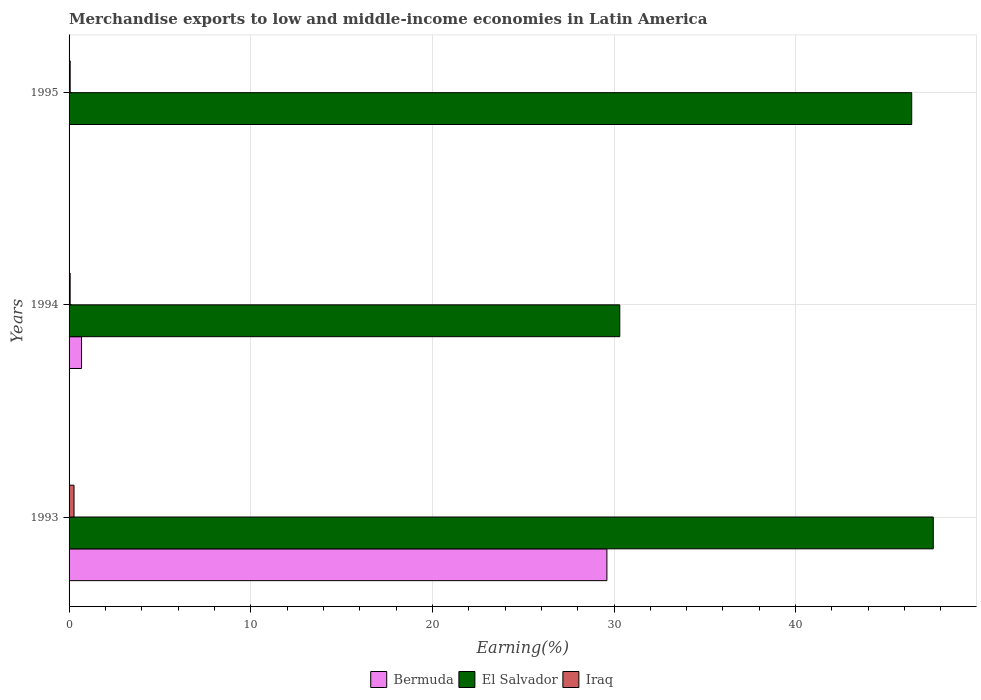How many groups of bars are there?
Provide a succinct answer. 3. How many bars are there on the 2nd tick from the top?
Ensure brevity in your answer.  3. What is the label of the 3rd group of bars from the top?
Provide a short and direct response. 1993. In how many cases, is the number of bars for a given year not equal to the number of legend labels?
Your response must be concise. 0. What is the percentage of amount earned from merchandise exports in Iraq in 1993?
Make the answer very short. 0.27. Across all years, what is the maximum percentage of amount earned from merchandise exports in Bermuda?
Keep it short and to the point. 29.61. Across all years, what is the minimum percentage of amount earned from merchandise exports in Iraq?
Keep it short and to the point. 0.06. In which year was the percentage of amount earned from merchandise exports in Bermuda maximum?
Your answer should be very brief. 1993. In which year was the percentage of amount earned from merchandise exports in Iraq minimum?
Your answer should be compact. 1994. What is the total percentage of amount earned from merchandise exports in Iraq in the graph?
Keep it short and to the point. 0.39. What is the difference between the percentage of amount earned from merchandise exports in Bermuda in 1993 and that in 1995?
Provide a short and direct response. 29.61. What is the difference between the percentage of amount earned from merchandise exports in Iraq in 1993 and the percentage of amount earned from merchandise exports in El Salvador in 1994?
Provide a succinct answer. -30.05. What is the average percentage of amount earned from merchandise exports in El Salvador per year?
Give a very brief answer. 41.43. In the year 1994, what is the difference between the percentage of amount earned from merchandise exports in El Salvador and percentage of amount earned from merchandise exports in Iraq?
Provide a short and direct response. 30.26. In how many years, is the percentage of amount earned from merchandise exports in Iraq greater than 46 %?
Provide a short and direct response. 0. What is the ratio of the percentage of amount earned from merchandise exports in El Salvador in 1994 to that in 1995?
Offer a terse response. 0.65. Is the difference between the percentage of amount earned from merchandise exports in El Salvador in 1993 and 1995 greater than the difference between the percentage of amount earned from merchandise exports in Iraq in 1993 and 1995?
Ensure brevity in your answer.  Yes. What is the difference between the highest and the second highest percentage of amount earned from merchandise exports in Iraq?
Your answer should be compact. 0.21. What is the difference between the highest and the lowest percentage of amount earned from merchandise exports in El Salvador?
Your answer should be very brief. 17.26. In how many years, is the percentage of amount earned from merchandise exports in El Salvador greater than the average percentage of amount earned from merchandise exports in El Salvador taken over all years?
Keep it short and to the point. 2. Is the sum of the percentage of amount earned from merchandise exports in Iraq in 1993 and 1994 greater than the maximum percentage of amount earned from merchandise exports in El Salvador across all years?
Make the answer very short. No. What does the 3rd bar from the top in 1993 represents?
Your answer should be very brief. Bermuda. What does the 2nd bar from the bottom in 1995 represents?
Provide a short and direct response. El Salvador. How many bars are there?
Offer a terse response. 9. What is the difference between two consecutive major ticks on the X-axis?
Make the answer very short. 10. Does the graph contain any zero values?
Ensure brevity in your answer.  No. Does the graph contain grids?
Provide a short and direct response. Yes. Where does the legend appear in the graph?
Provide a succinct answer. Bottom center. What is the title of the graph?
Make the answer very short. Merchandise exports to low and middle-income economies in Latin America. Does "Czech Republic" appear as one of the legend labels in the graph?
Provide a short and direct response. No. What is the label or title of the X-axis?
Provide a short and direct response. Earning(%). What is the label or title of the Y-axis?
Offer a terse response. Years. What is the Earning(%) of Bermuda in 1993?
Your answer should be compact. 29.61. What is the Earning(%) of El Salvador in 1993?
Your response must be concise. 47.58. What is the Earning(%) of Iraq in 1993?
Your answer should be compact. 0.27. What is the Earning(%) of Bermuda in 1994?
Give a very brief answer. 0.69. What is the Earning(%) of El Salvador in 1994?
Offer a terse response. 30.32. What is the Earning(%) in Iraq in 1994?
Offer a very short reply. 0.06. What is the Earning(%) of Bermuda in 1995?
Your response must be concise. 8.26324880050998e-5. What is the Earning(%) of El Salvador in 1995?
Offer a very short reply. 46.39. What is the Earning(%) in Iraq in 1995?
Give a very brief answer. 0.06. Across all years, what is the maximum Earning(%) of Bermuda?
Offer a very short reply. 29.61. Across all years, what is the maximum Earning(%) of El Salvador?
Offer a very short reply. 47.58. Across all years, what is the maximum Earning(%) of Iraq?
Provide a succinct answer. 0.27. Across all years, what is the minimum Earning(%) of Bermuda?
Give a very brief answer. 8.26324880050998e-5. Across all years, what is the minimum Earning(%) of El Salvador?
Your answer should be compact. 30.32. Across all years, what is the minimum Earning(%) in Iraq?
Your answer should be very brief. 0.06. What is the total Earning(%) of Bermuda in the graph?
Give a very brief answer. 30.3. What is the total Earning(%) in El Salvador in the graph?
Give a very brief answer. 124.28. What is the total Earning(%) of Iraq in the graph?
Ensure brevity in your answer.  0.39. What is the difference between the Earning(%) in Bermuda in 1993 and that in 1994?
Give a very brief answer. 28.92. What is the difference between the Earning(%) in El Salvador in 1993 and that in 1994?
Offer a very short reply. 17.26. What is the difference between the Earning(%) in Iraq in 1993 and that in 1994?
Provide a short and direct response. 0.21. What is the difference between the Earning(%) in Bermuda in 1993 and that in 1995?
Your response must be concise. 29.61. What is the difference between the Earning(%) of El Salvador in 1993 and that in 1995?
Offer a terse response. 1.19. What is the difference between the Earning(%) in Iraq in 1993 and that in 1995?
Offer a terse response. 0.21. What is the difference between the Earning(%) in Bermuda in 1994 and that in 1995?
Provide a succinct answer. 0.69. What is the difference between the Earning(%) in El Salvador in 1994 and that in 1995?
Provide a short and direct response. -16.07. What is the difference between the Earning(%) of Iraq in 1994 and that in 1995?
Your answer should be very brief. -0. What is the difference between the Earning(%) in Bermuda in 1993 and the Earning(%) in El Salvador in 1994?
Give a very brief answer. -0.71. What is the difference between the Earning(%) of Bermuda in 1993 and the Earning(%) of Iraq in 1994?
Ensure brevity in your answer.  29.55. What is the difference between the Earning(%) of El Salvador in 1993 and the Earning(%) of Iraq in 1994?
Provide a short and direct response. 47.52. What is the difference between the Earning(%) of Bermuda in 1993 and the Earning(%) of El Salvador in 1995?
Keep it short and to the point. -16.78. What is the difference between the Earning(%) in Bermuda in 1993 and the Earning(%) in Iraq in 1995?
Give a very brief answer. 29.55. What is the difference between the Earning(%) of El Salvador in 1993 and the Earning(%) of Iraq in 1995?
Provide a succinct answer. 47.52. What is the difference between the Earning(%) in Bermuda in 1994 and the Earning(%) in El Salvador in 1995?
Ensure brevity in your answer.  -45.7. What is the difference between the Earning(%) in Bermuda in 1994 and the Earning(%) in Iraq in 1995?
Your response must be concise. 0.63. What is the difference between the Earning(%) of El Salvador in 1994 and the Earning(%) of Iraq in 1995?
Your answer should be very brief. 30.26. What is the average Earning(%) in Bermuda per year?
Provide a short and direct response. 10.1. What is the average Earning(%) of El Salvador per year?
Your answer should be very brief. 41.43. What is the average Earning(%) in Iraq per year?
Your answer should be compact. 0.13. In the year 1993, what is the difference between the Earning(%) in Bermuda and Earning(%) in El Salvador?
Ensure brevity in your answer.  -17.97. In the year 1993, what is the difference between the Earning(%) of Bermuda and Earning(%) of Iraq?
Your answer should be very brief. 29.34. In the year 1993, what is the difference between the Earning(%) in El Salvador and Earning(%) in Iraq?
Ensure brevity in your answer.  47.3. In the year 1994, what is the difference between the Earning(%) in Bermuda and Earning(%) in El Salvador?
Make the answer very short. -29.63. In the year 1994, what is the difference between the Earning(%) of Bermuda and Earning(%) of Iraq?
Your response must be concise. 0.63. In the year 1994, what is the difference between the Earning(%) in El Salvador and Earning(%) in Iraq?
Your answer should be compact. 30.26. In the year 1995, what is the difference between the Earning(%) of Bermuda and Earning(%) of El Salvador?
Keep it short and to the point. -46.39. In the year 1995, what is the difference between the Earning(%) in Bermuda and Earning(%) in Iraq?
Make the answer very short. -0.06. In the year 1995, what is the difference between the Earning(%) of El Salvador and Earning(%) of Iraq?
Your response must be concise. 46.33. What is the ratio of the Earning(%) in Bermuda in 1993 to that in 1994?
Give a very brief answer. 43.1. What is the ratio of the Earning(%) in El Salvador in 1993 to that in 1994?
Your answer should be very brief. 1.57. What is the ratio of the Earning(%) in Iraq in 1993 to that in 1994?
Ensure brevity in your answer.  4.54. What is the ratio of the Earning(%) of Bermuda in 1993 to that in 1995?
Your answer should be very brief. 3.58e+05. What is the ratio of the Earning(%) in El Salvador in 1993 to that in 1995?
Offer a terse response. 1.03. What is the ratio of the Earning(%) in Iraq in 1993 to that in 1995?
Your answer should be very brief. 4.49. What is the ratio of the Earning(%) of Bermuda in 1994 to that in 1995?
Keep it short and to the point. 8313.64. What is the ratio of the Earning(%) of El Salvador in 1994 to that in 1995?
Ensure brevity in your answer.  0.65. What is the ratio of the Earning(%) of Iraq in 1994 to that in 1995?
Your response must be concise. 0.99. What is the difference between the highest and the second highest Earning(%) in Bermuda?
Your answer should be very brief. 28.92. What is the difference between the highest and the second highest Earning(%) in El Salvador?
Your response must be concise. 1.19. What is the difference between the highest and the second highest Earning(%) in Iraq?
Ensure brevity in your answer.  0.21. What is the difference between the highest and the lowest Earning(%) of Bermuda?
Your answer should be very brief. 29.61. What is the difference between the highest and the lowest Earning(%) in El Salvador?
Your response must be concise. 17.26. What is the difference between the highest and the lowest Earning(%) in Iraq?
Your answer should be compact. 0.21. 